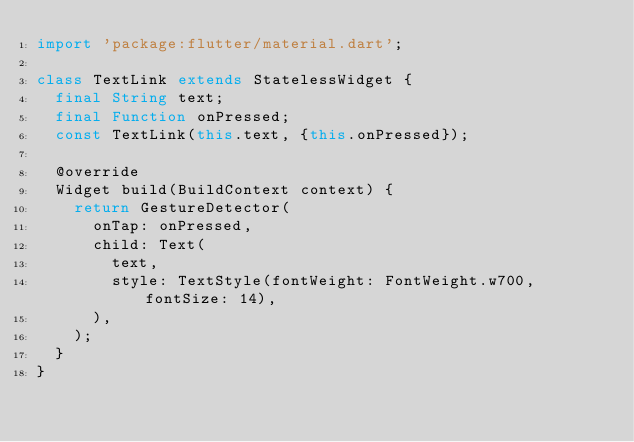Convert code to text. <code><loc_0><loc_0><loc_500><loc_500><_Dart_>import 'package:flutter/material.dart';

class TextLink extends StatelessWidget {
  final String text;
  final Function onPressed;
  const TextLink(this.text, {this.onPressed});

  @override
  Widget build(BuildContext context) {
    return GestureDetector(
      onTap: onPressed,
      child: Text(
        text,
        style: TextStyle(fontWeight: FontWeight.w700, fontSize: 14),
      ),
    );
  }
}
</code> 